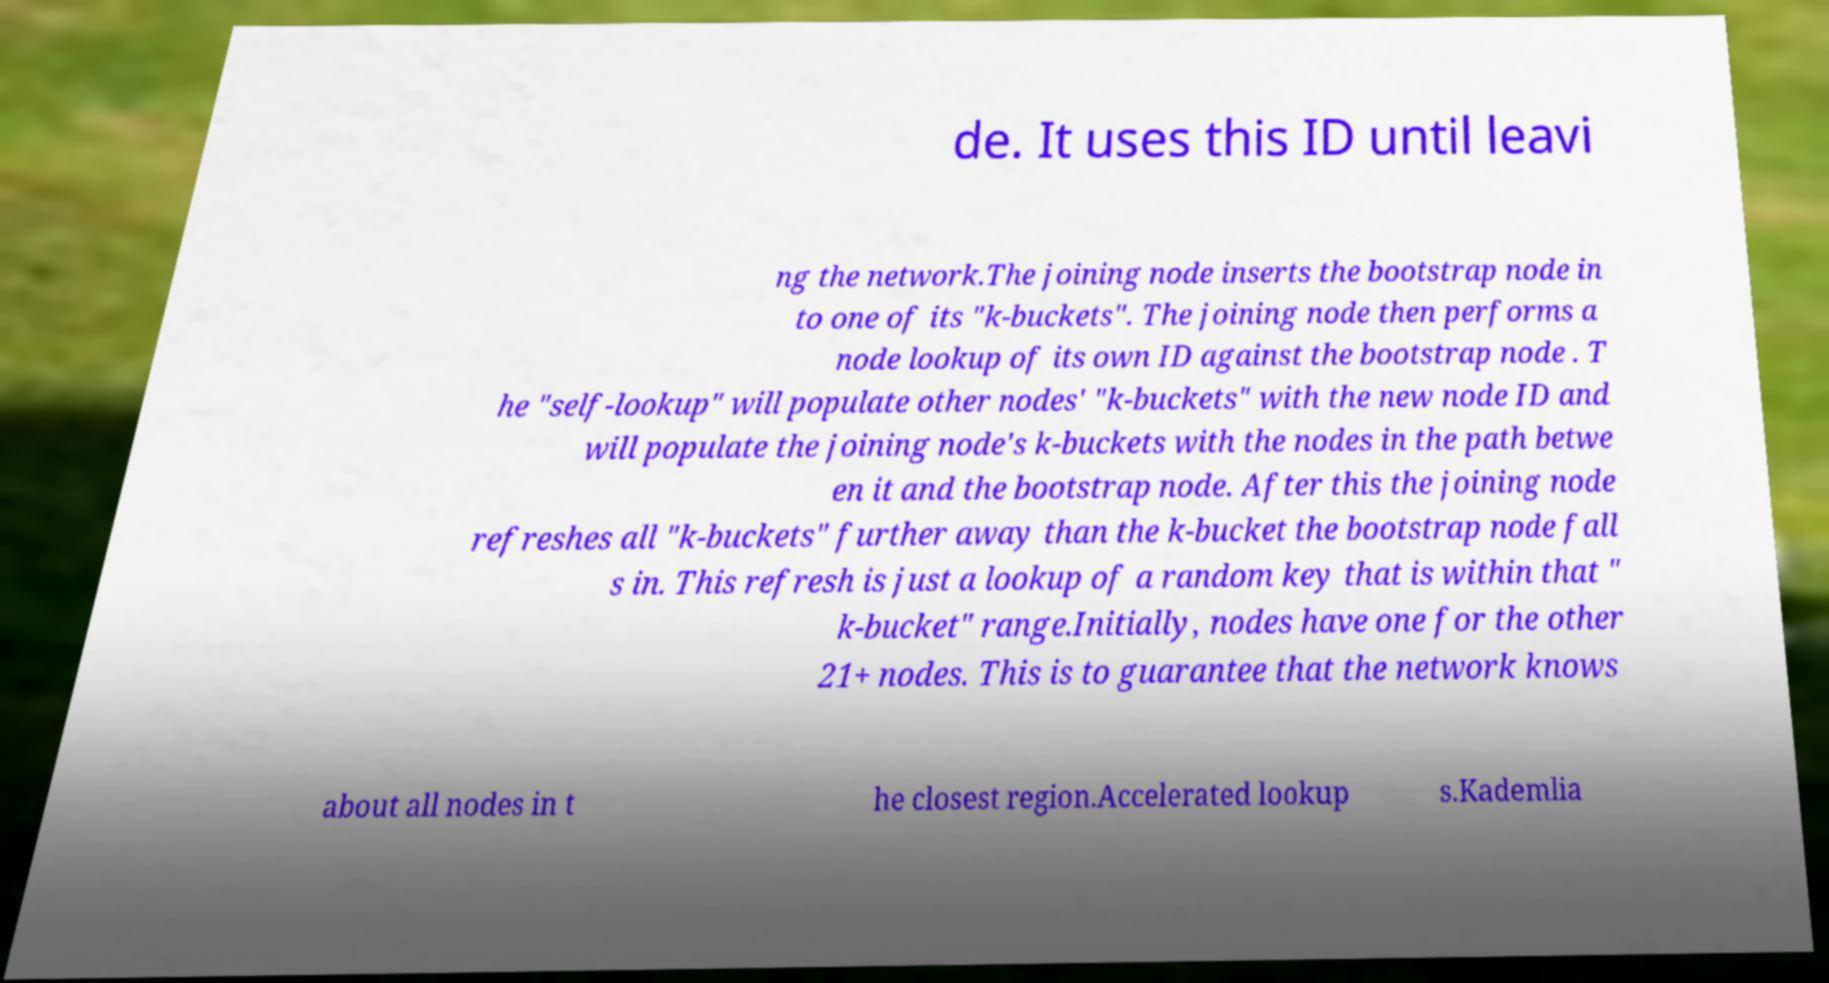Can you read and provide the text displayed in the image?This photo seems to have some interesting text. Can you extract and type it out for me? de. It uses this ID until leavi ng the network.The joining node inserts the bootstrap node in to one of its "k-buckets". The joining node then performs a node lookup of its own ID against the bootstrap node . T he "self-lookup" will populate other nodes' "k-buckets" with the new node ID and will populate the joining node's k-buckets with the nodes in the path betwe en it and the bootstrap node. After this the joining node refreshes all "k-buckets" further away than the k-bucket the bootstrap node fall s in. This refresh is just a lookup of a random key that is within that " k-bucket" range.Initially, nodes have one for the other 21+ nodes. This is to guarantee that the network knows about all nodes in t he closest region.Accelerated lookup s.Kademlia 